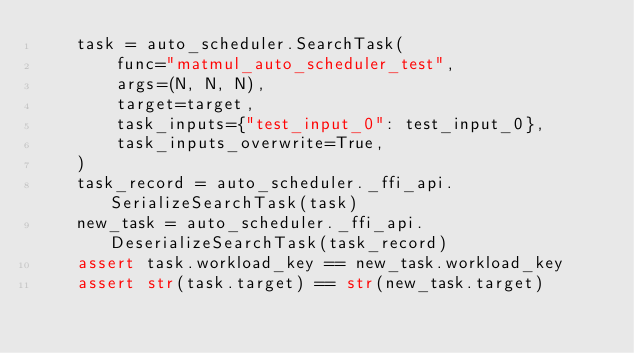<code> <loc_0><loc_0><loc_500><loc_500><_Python_>    task = auto_scheduler.SearchTask(
        func="matmul_auto_scheduler_test",
        args=(N, N, N),
        target=target,
        task_inputs={"test_input_0": test_input_0},
        task_inputs_overwrite=True,
    )
    task_record = auto_scheduler._ffi_api.SerializeSearchTask(task)
    new_task = auto_scheduler._ffi_api.DeserializeSearchTask(task_record)
    assert task.workload_key == new_task.workload_key
    assert str(task.target) == str(new_task.target)</code> 